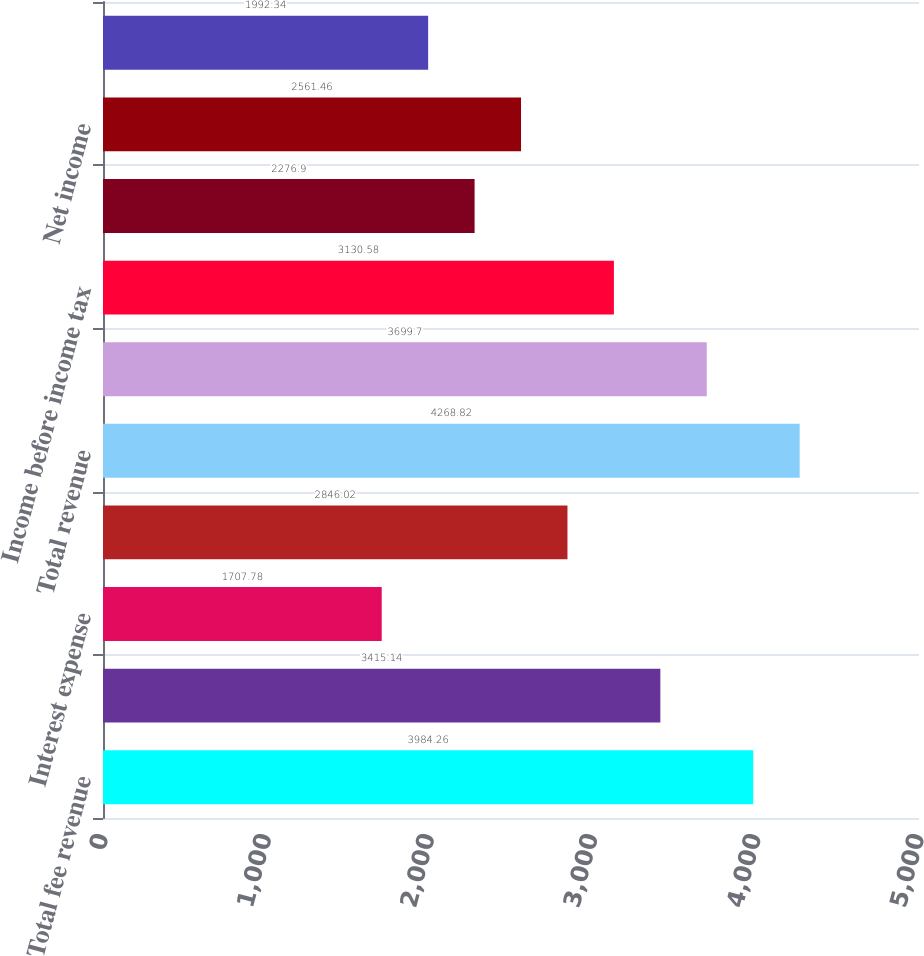Convert chart. <chart><loc_0><loc_0><loc_500><loc_500><bar_chart><fcel>Total fee revenue<fcel>Interest income<fcel>Interest expense<fcel>Net interest income<fcel>Total revenue<fcel>Total expenses<fcel>Income before income tax<fcel>Income tax expense (benefit)<fcel>Net income<fcel>Net income available to common<nl><fcel>3984.26<fcel>3415.14<fcel>1707.78<fcel>2846.02<fcel>4268.82<fcel>3699.7<fcel>3130.58<fcel>2276.9<fcel>2561.46<fcel>1992.34<nl></chart> 